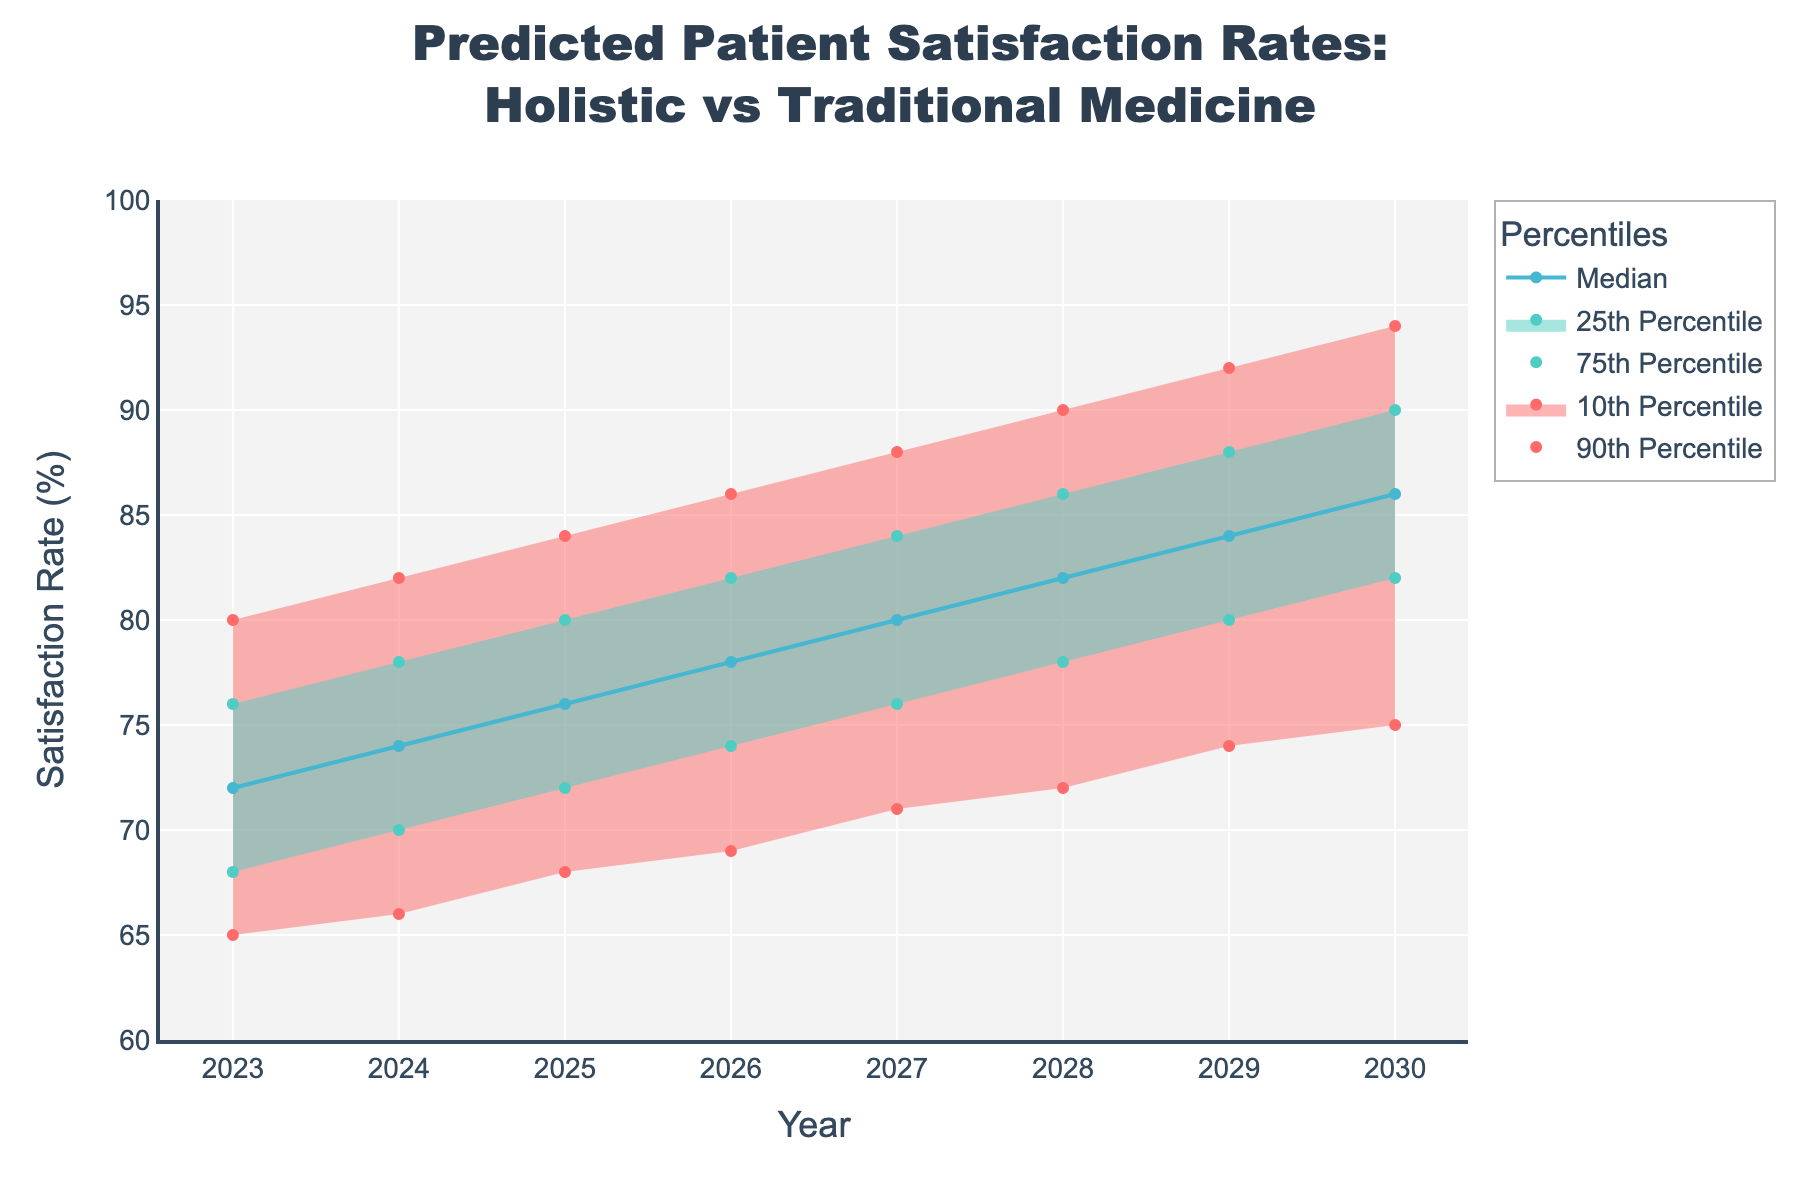What is the title of the plot? The title is clearly displayed at the top of the figure. It reads, "Predicted Patient Satisfaction Rates:<br>Holistic vs Traditional Medicine".
Answer: Predicted Patient Satisfaction Rates: Holistic vs Traditional Medicine How many years are shown in the plot? By counting the distinct points on the x-axis representing years, we observe that it ranges from 2023 to 2030.
Answer: 8 years What is the median satisfaction rate predicted for 2027? Locate the median line on the plot and find its value at the year 2027, which is 80%.
Answer: 80% How does the predicted 75th percentile satisfaction rate change from 2023 to 2030? Observe the values of the 75th percentile in 2023 and 2030. In 2023, it is 76%, and in 2030, it is 90%. The difference is 90% - 76%.
Answer: Increases by 14% Between which years does the median satisfaction rate increase the most? Calculate the year-on-year difference for the median values and identify the highest. The differences are 2% per year from 2023 to 2030, so any year could be the answer since each increment is the same.
Answer: Between any consecutive years Which percentile has the smallest predicted increase from 2023 to 2030? Calculate the increase for each percentile from 2023 to 2030. For the 10th percentile, the increase is 75 - 65 = 10%. For the 25th percentile, it is 82 - 68 = 14%. For the 75th percentile, it is 90 - 76 = 14%, and for the 90th percentile, it is 94 - 80 = 14%. The 10th percentile shows the smallest increase.
Answer: 10th Percentile By how many percentage points does the upper 90% percentile satisfaction rate increase between 2023 and 2028? Find the upper 90% values for 2023 (80%) and 2028 (90%), then compute the difference: 90% - 80% = 10%.
Answer: 10% Does the plot show any prediction for a decrease in satisfaction rates over time? Review the trends of median and other confidence intervals over the years. All lines show an upward trend.
Answer: No What is the interquartile range of patient satisfaction rates in 2025? The interquartile range is calculated by subtracting the 25th percentile from the 75th percentile for 2025 (80% - 72%).
Answer: 8% Between 2024 and 2026, how much does the lower 25% percentile satisfaction rate change? Look at the values for the lower 25% in 2024 and 2026. The difference is 74% - 70%.
Answer: 4% 